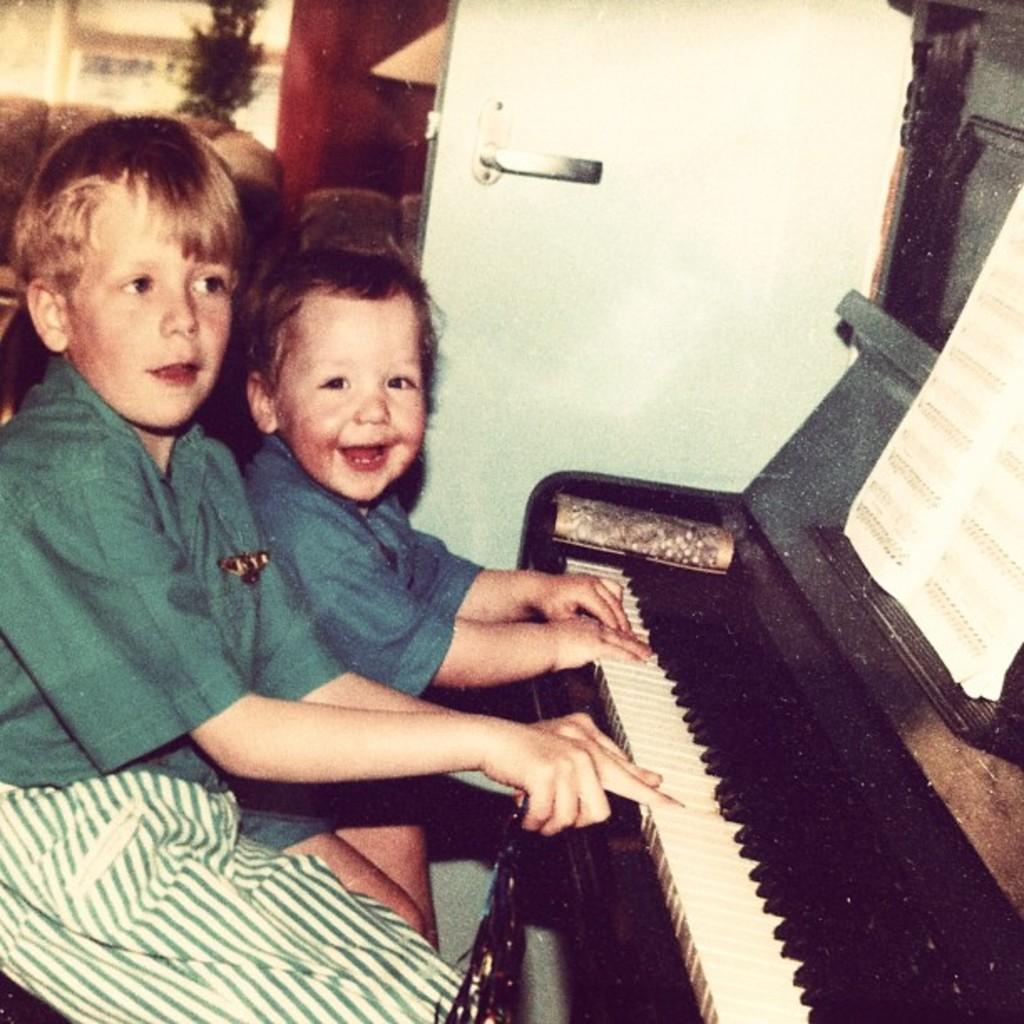In one or two sentences, can you explain what this image depicts? In this image, two kids are playing a musical instrument. They are smiling. On right side, we can see book. At the background, there is a door, sofa, couch, plant and wall, window. 